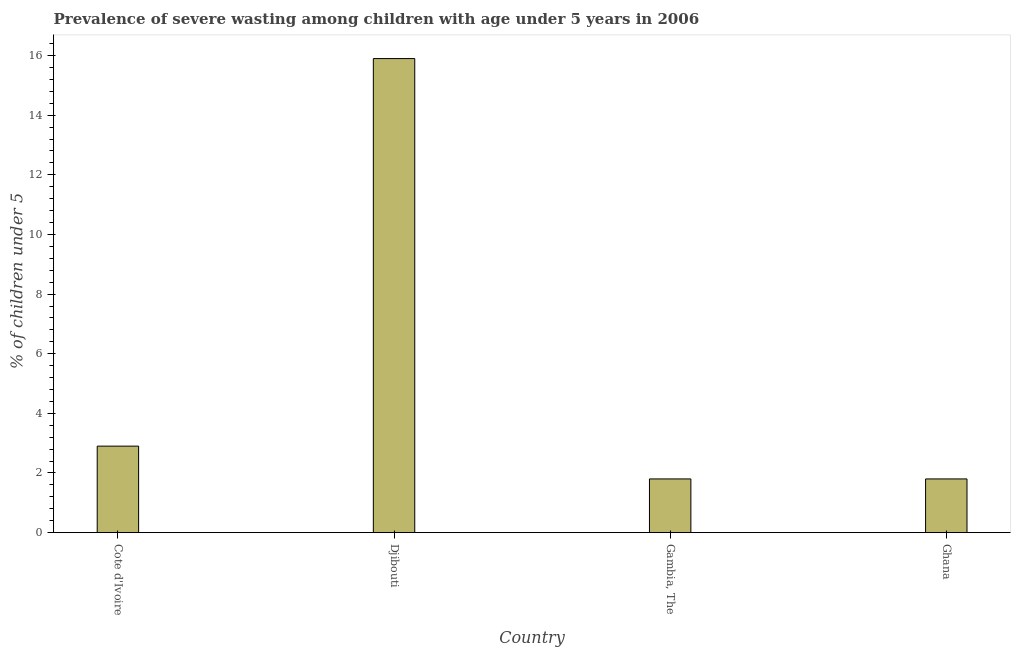Does the graph contain any zero values?
Offer a very short reply. No. What is the title of the graph?
Keep it short and to the point. Prevalence of severe wasting among children with age under 5 years in 2006. What is the label or title of the Y-axis?
Provide a succinct answer.  % of children under 5. What is the prevalence of severe wasting in Gambia, The?
Keep it short and to the point. 1.8. Across all countries, what is the maximum prevalence of severe wasting?
Your answer should be compact. 15.9. Across all countries, what is the minimum prevalence of severe wasting?
Offer a very short reply. 1.8. In which country was the prevalence of severe wasting maximum?
Your answer should be compact. Djibouti. In which country was the prevalence of severe wasting minimum?
Your answer should be compact. Gambia, The. What is the sum of the prevalence of severe wasting?
Offer a very short reply. 22.4. What is the difference between the prevalence of severe wasting in Cote d'Ivoire and Gambia, The?
Give a very brief answer. 1.1. What is the average prevalence of severe wasting per country?
Offer a very short reply. 5.6. What is the median prevalence of severe wasting?
Offer a very short reply. 2.35. What is the ratio of the prevalence of severe wasting in Gambia, The to that in Ghana?
Offer a terse response. 1. Is the prevalence of severe wasting in Djibouti less than that in Gambia, The?
Keep it short and to the point. No. Is the difference between the prevalence of severe wasting in Cote d'Ivoire and Djibouti greater than the difference between any two countries?
Offer a very short reply. No. Is the sum of the prevalence of severe wasting in Cote d'Ivoire and Gambia, The greater than the maximum prevalence of severe wasting across all countries?
Your answer should be compact. No. What is the difference between the highest and the lowest prevalence of severe wasting?
Give a very brief answer. 14.1. Are all the bars in the graph horizontal?
Your response must be concise. No. What is the difference between two consecutive major ticks on the Y-axis?
Make the answer very short. 2. Are the values on the major ticks of Y-axis written in scientific E-notation?
Make the answer very short. No. What is the  % of children under 5 in Cote d'Ivoire?
Keep it short and to the point. 2.9. What is the  % of children under 5 of Djibouti?
Offer a very short reply. 15.9. What is the  % of children under 5 in Gambia, The?
Make the answer very short. 1.8. What is the  % of children under 5 of Ghana?
Give a very brief answer. 1.8. What is the difference between the  % of children under 5 in Cote d'Ivoire and Gambia, The?
Provide a short and direct response. 1.1. What is the difference between the  % of children under 5 in Djibouti and Ghana?
Provide a succinct answer. 14.1. What is the ratio of the  % of children under 5 in Cote d'Ivoire to that in Djibouti?
Ensure brevity in your answer.  0.18. What is the ratio of the  % of children under 5 in Cote d'Ivoire to that in Gambia, The?
Ensure brevity in your answer.  1.61. What is the ratio of the  % of children under 5 in Cote d'Ivoire to that in Ghana?
Provide a succinct answer. 1.61. What is the ratio of the  % of children under 5 in Djibouti to that in Gambia, The?
Give a very brief answer. 8.83. What is the ratio of the  % of children under 5 in Djibouti to that in Ghana?
Provide a short and direct response. 8.83. 